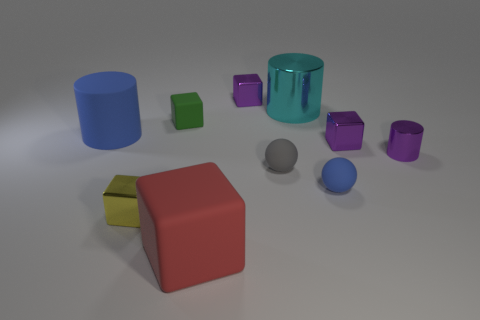Do the objects share a common color scheme or are they all different? The objects feature different colors including shades of blue, green, purple, and a singular item in red. There does not appear to be a consistent color scheme. Which object stands out the most to you? The red cube stands out due to its larger size and its vibrant color contrast with the rest of the items. 